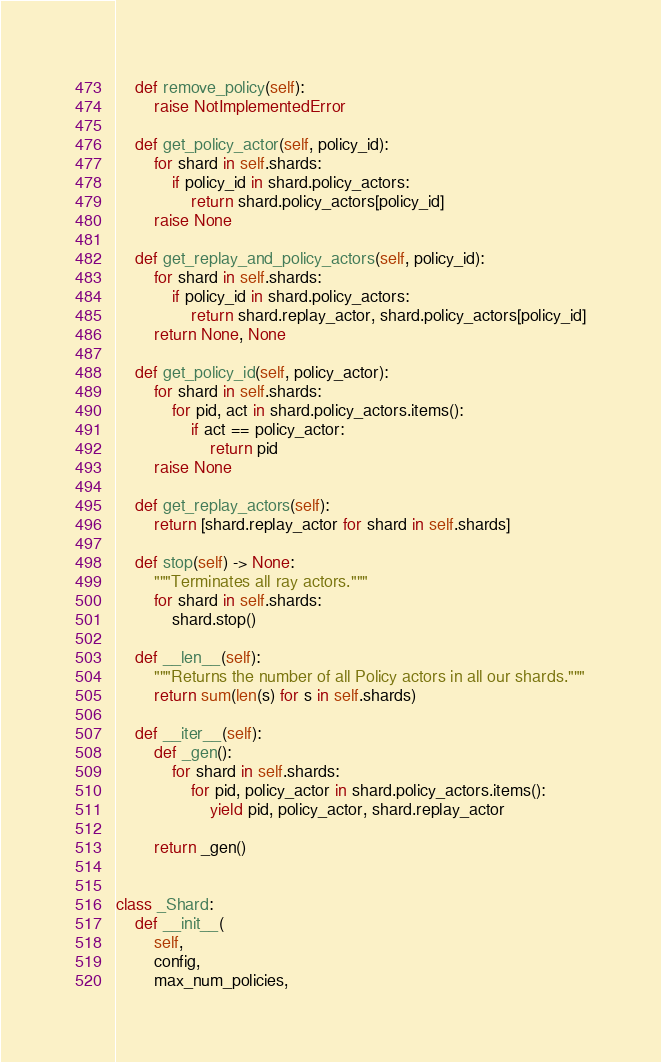<code> <loc_0><loc_0><loc_500><loc_500><_Python_>    def remove_policy(self):
        raise NotImplementedError

    def get_policy_actor(self, policy_id):
        for shard in self.shards:
            if policy_id in shard.policy_actors:
                return shard.policy_actors[policy_id]
        raise None

    def get_replay_and_policy_actors(self, policy_id):
        for shard in self.shards:
            if policy_id in shard.policy_actors:
                return shard.replay_actor, shard.policy_actors[policy_id]
        return None, None

    def get_policy_id(self, policy_actor):
        for shard in self.shards:
            for pid, act in shard.policy_actors.items():
                if act == policy_actor:
                    return pid
        raise None

    def get_replay_actors(self):
        return [shard.replay_actor for shard in self.shards]

    def stop(self) -> None:
        """Terminates all ray actors."""
        for shard in self.shards:
            shard.stop()

    def __len__(self):
        """Returns the number of all Policy actors in all our shards."""
        return sum(len(s) for s in self.shards)

    def __iter__(self):
        def _gen():
            for shard in self.shards:
                for pid, policy_actor in shard.policy_actors.items():
                    yield pid, policy_actor, shard.replay_actor

        return _gen()


class _Shard:
    def __init__(
        self,
        config,
        max_num_policies,</code> 